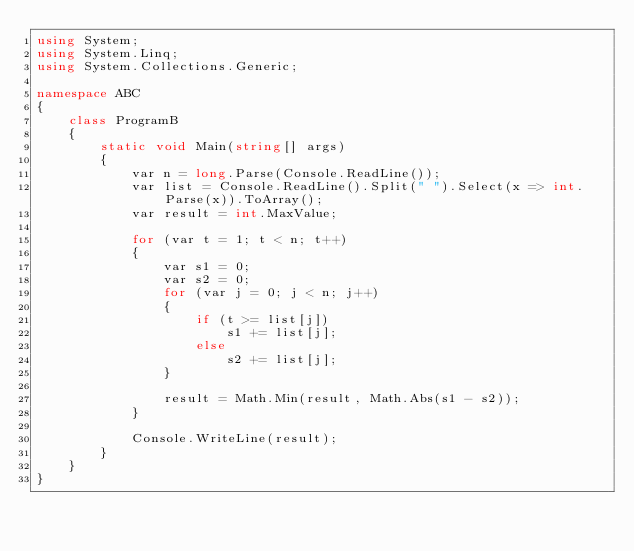<code> <loc_0><loc_0><loc_500><loc_500><_C#_>using System;
using System.Linq;
using System.Collections.Generic;

namespace ABC
{
    class ProgramB
    {
        static void Main(string[] args)
        {
            var n = long.Parse(Console.ReadLine());
            var list = Console.ReadLine().Split(" ").Select(x => int.Parse(x)).ToArray();
            var result = int.MaxValue;

            for (var t = 1; t < n; t++)
            {
                var s1 = 0;
                var s2 = 0;
                for (var j = 0; j < n; j++)
                {
                    if (t >= list[j])
                        s1 += list[j];
                    else
                        s2 += list[j];
                }

                result = Math.Min(result, Math.Abs(s1 - s2));
            }

            Console.WriteLine(result);
        }
    }
}
</code> 